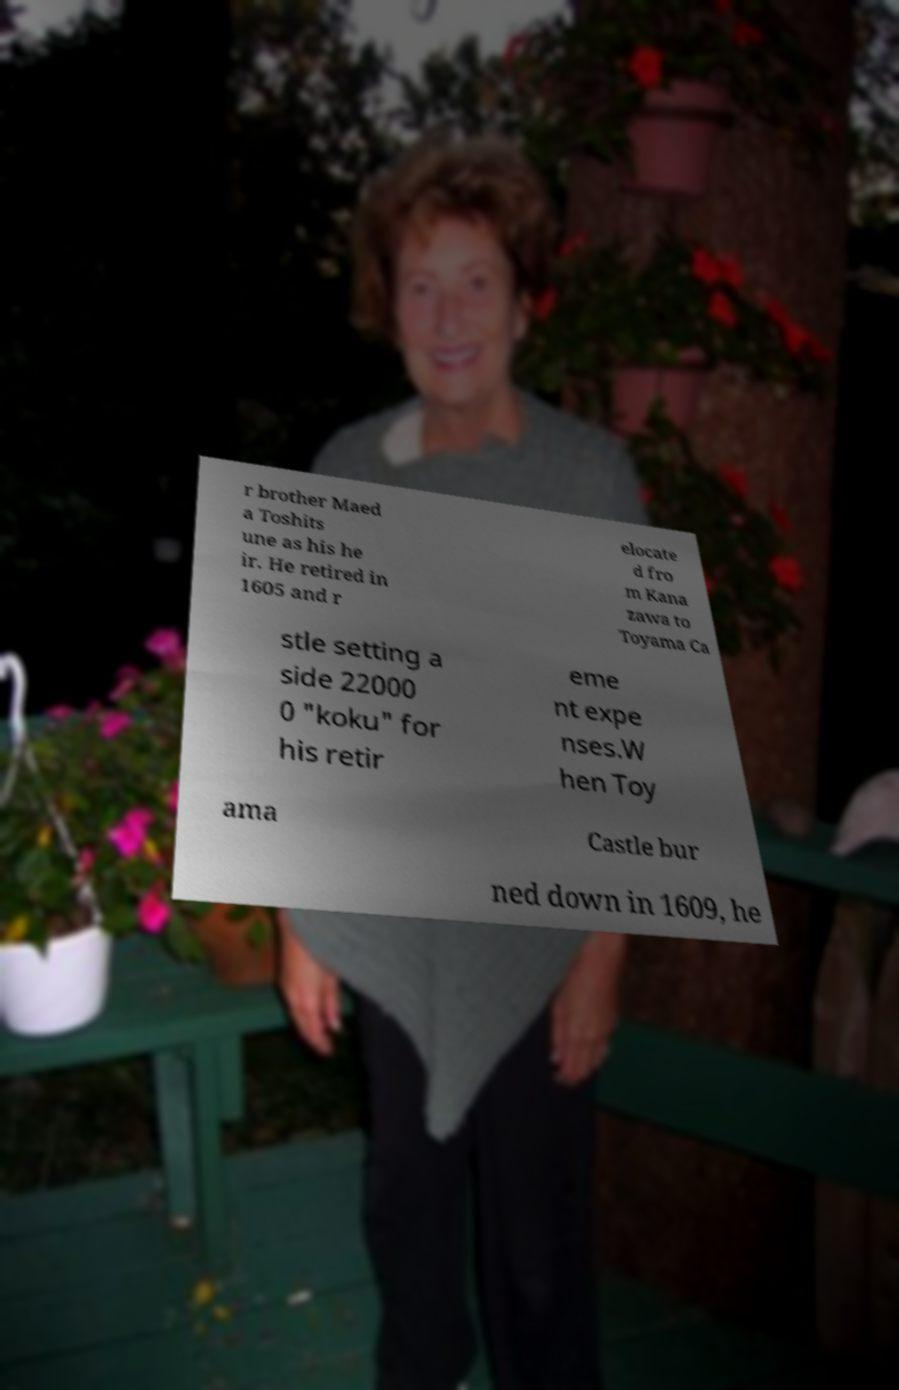Can you read and provide the text displayed in the image?This photo seems to have some interesting text. Can you extract and type it out for me? r brother Maed a Toshits une as his he ir. He retired in 1605 and r elocate d fro m Kana zawa to Toyama Ca stle setting a side 22000 0 "koku" for his retir eme nt expe nses.W hen Toy ama Castle bur ned down in 1609, he 